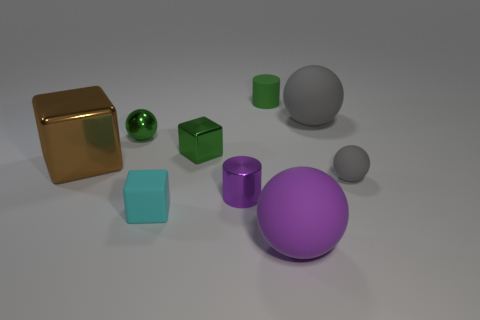Add 1 rubber cylinders. How many objects exist? 10 Subtract all blocks. How many objects are left? 6 Subtract all big gray things. Subtract all gray rubber objects. How many objects are left? 6 Add 5 tiny rubber cylinders. How many tiny rubber cylinders are left? 6 Add 5 metal objects. How many metal objects exist? 9 Subtract 0 cyan spheres. How many objects are left? 9 